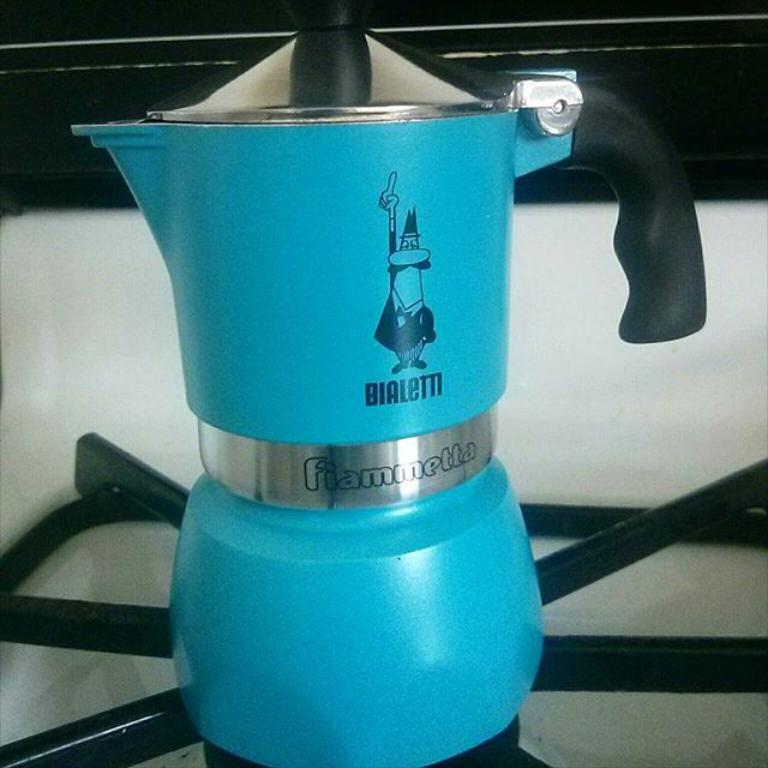<image>
Relay a brief, clear account of the picture shown. A blue kettle with BIALETTI written on the side 